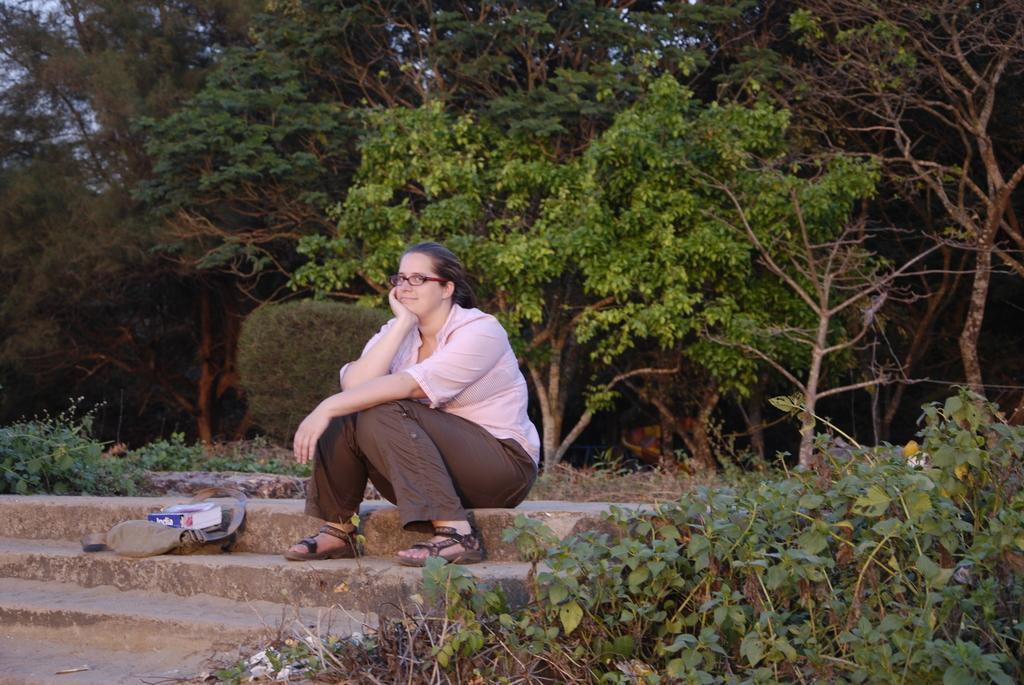Describe this image in one or two sentences. Here we can see a woman posing to a camera and she has spectacles. There is a bag and a book. Here we can see plants. In the background there are trees and sky. 